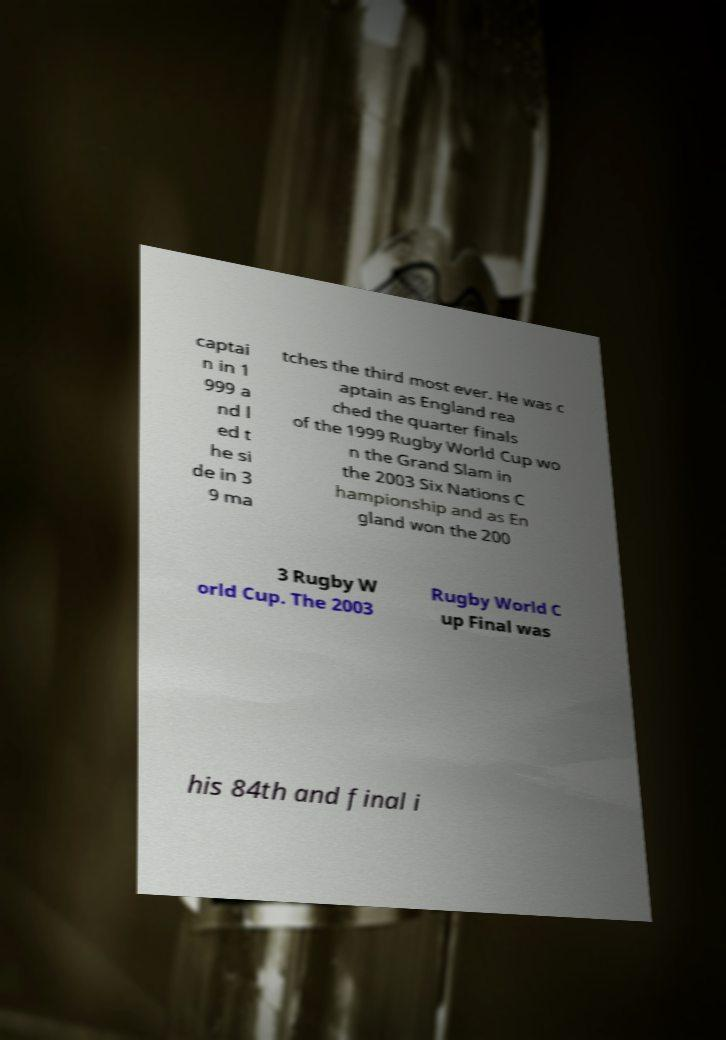Could you assist in decoding the text presented in this image and type it out clearly? captai n in 1 999 a nd l ed t he si de in 3 9 ma tches the third most ever. He was c aptain as England rea ched the quarter finals of the 1999 Rugby World Cup wo n the Grand Slam in the 2003 Six Nations C hampionship and as En gland won the 200 3 Rugby W orld Cup. The 2003 Rugby World C up Final was his 84th and final i 